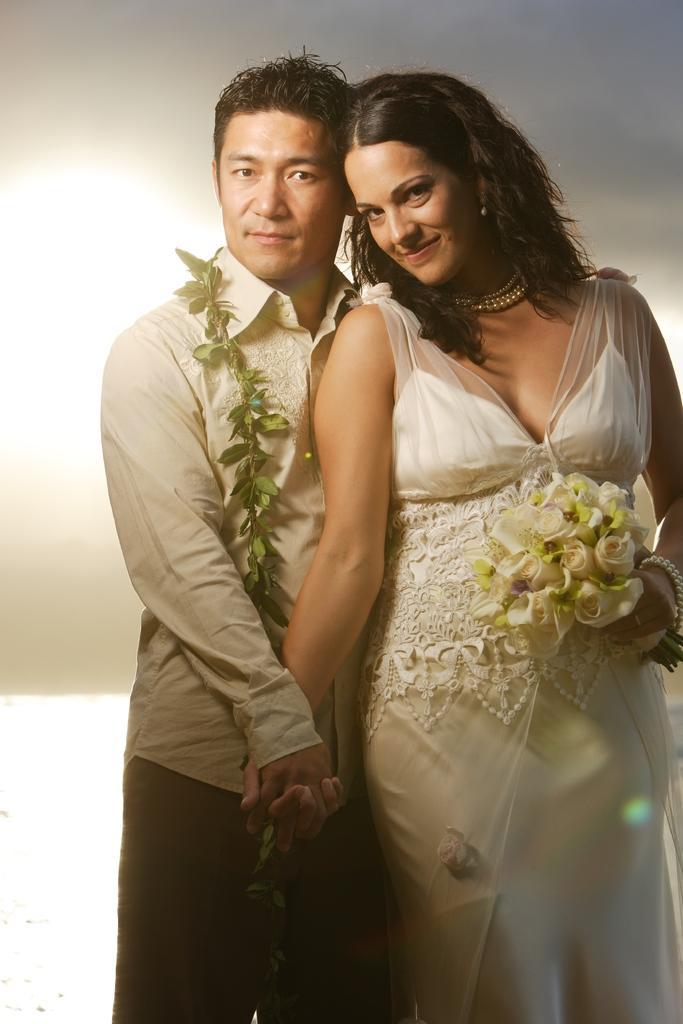Describe this image in one or two sentences. This picture shows a man and a woman standing holding their hands and we see few leaves in the man's neck and flowers in the women's hand and we see women wore ornaments on her neck and we see man wore white color shirt and women wore white color dress and we see a white color background. 